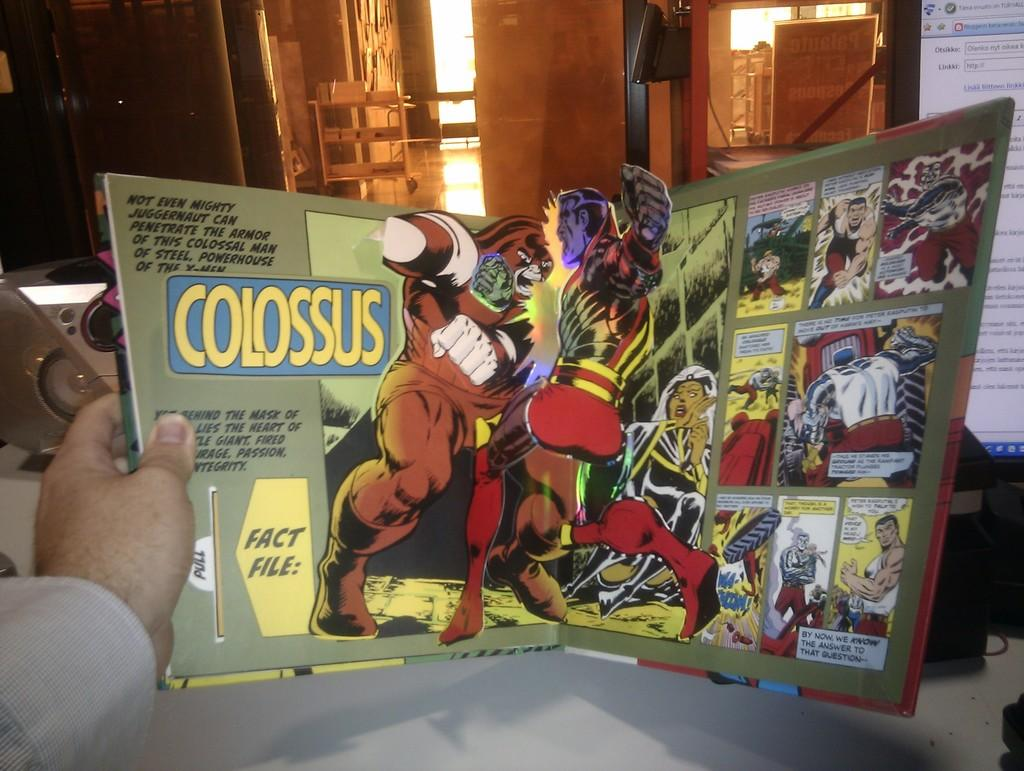Provide a one-sentence caption for the provided image. A man holding a comic book called Colossus open a table. 